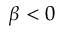<formula> <loc_0><loc_0><loc_500><loc_500>\beta < 0</formula> 